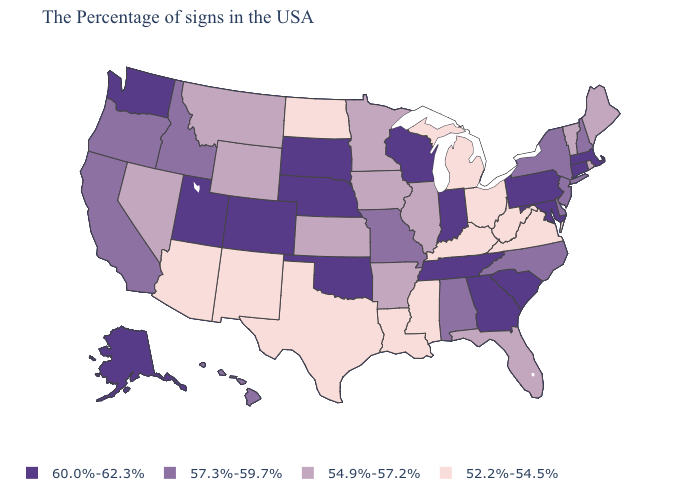What is the lowest value in the USA?
Be succinct. 52.2%-54.5%. Which states have the highest value in the USA?
Answer briefly. Massachusetts, Connecticut, Maryland, Pennsylvania, South Carolina, Georgia, Indiana, Tennessee, Wisconsin, Nebraska, Oklahoma, South Dakota, Colorado, Utah, Washington, Alaska. Does Ohio have the lowest value in the USA?
Concise answer only. Yes. What is the value of Wyoming?
Be succinct. 54.9%-57.2%. What is the value of New Jersey?
Short answer required. 57.3%-59.7%. What is the value of Arizona?
Concise answer only. 52.2%-54.5%. Does Pennsylvania have the highest value in the USA?
Short answer required. Yes. What is the lowest value in the USA?
Give a very brief answer. 52.2%-54.5%. Is the legend a continuous bar?
Concise answer only. No. Name the states that have a value in the range 54.9%-57.2%?
Give a very brief answer. Maine, Rhode Island, Vermont, Florida, Illinois, Arkansas, Minnesota, Iowa, Kansas, Wyoming, Montana, Nevada. What is the value of Hawaii?
Write a very short answer. 57.3%-59.7%. Among the states that border Idaho , which have the lowest value?
Write a very short answer. Wyoming, Montana, Nevada. Does Nevada have the same value as Nebraska?
Short answer required. No. What is the value of South Dakota?
Quick response, please. 60.0%-62.3%. Does the first symbol in the legend represent the smallest category?
Be succinct. No. 